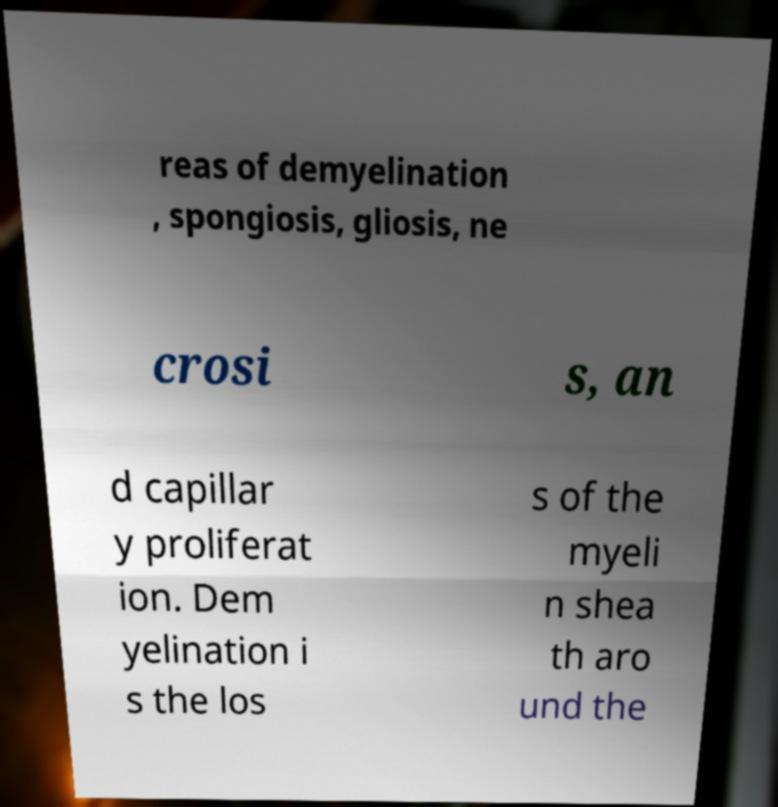Please identify and transcribe the text found in this image. reas of demyelination , spongiosis, gliosis, ne crosi s, an d capillar y proliferat ion. Dem yelination i s the los s of the myeli n shea th aro und the 